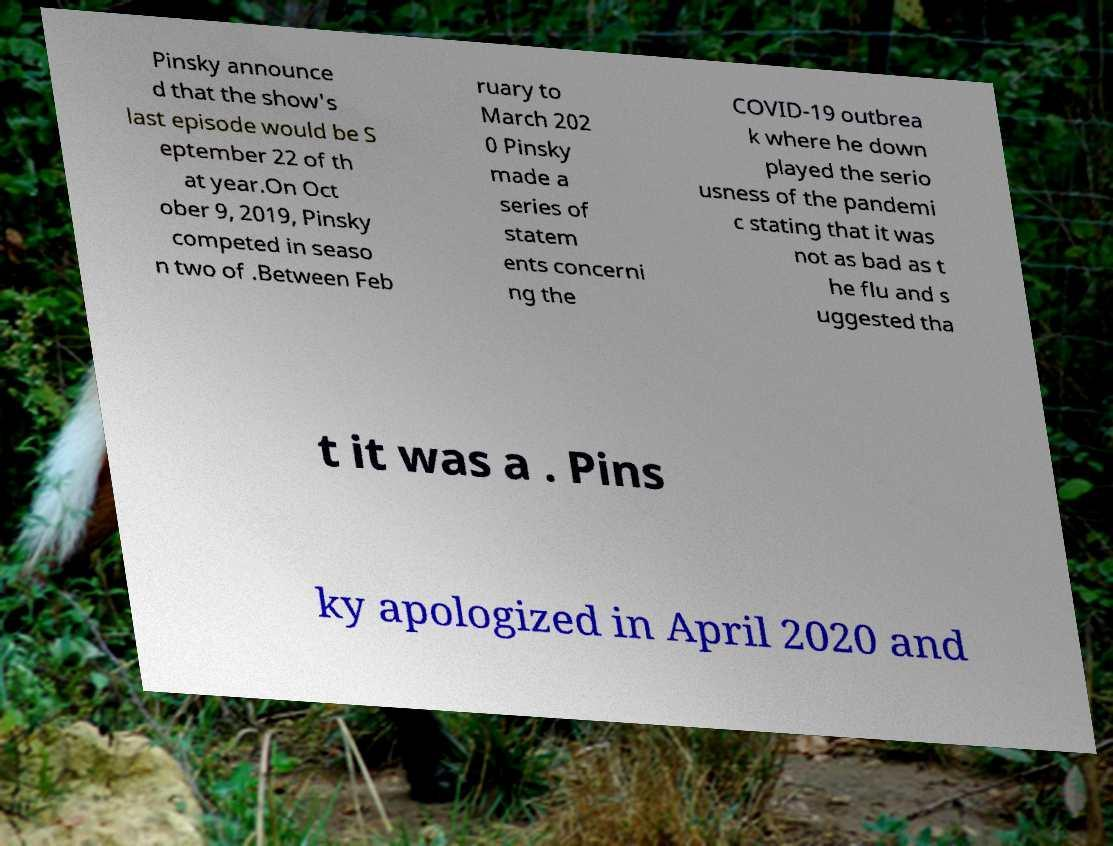There's text embedded in this image that I need extracted. Can you transcribe it verbatim? Pinsky announce d that the show's last episode would be S eptember 22 of th at year.On Oct ober 9, 2019, Pinsky competed in seaso n two of .Between Feb ruary to March 202 0 Pinsky made a series of statem ents concerni ng the COVID-19 outbrea k where he down played the serio usness of the pandemi c stating that it was not as bad as t he flu and s uggested tha t it was a . Pins ky apologized in April 2020 and 